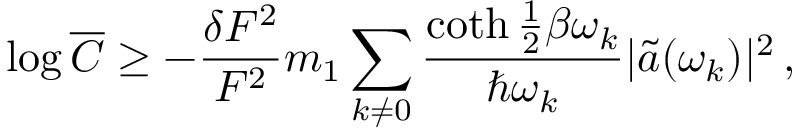Convert formula to latex. <formula><loc_0><loc_0><loc_500><loc_500>\log \overline { C } \geq - \frac { \delta F ^ { 2 } } { F ^ { 2 } } m _ { 1 } \sum _ { k \ne 0 } \frac { \coth \frac { 1 } { 2 } \beta \omega _ { k } } { \hbar { \omega } _ { k } } | \tilde { a } ( \omega _ { k } ) | ^ { 2 } \, ,</formula> 